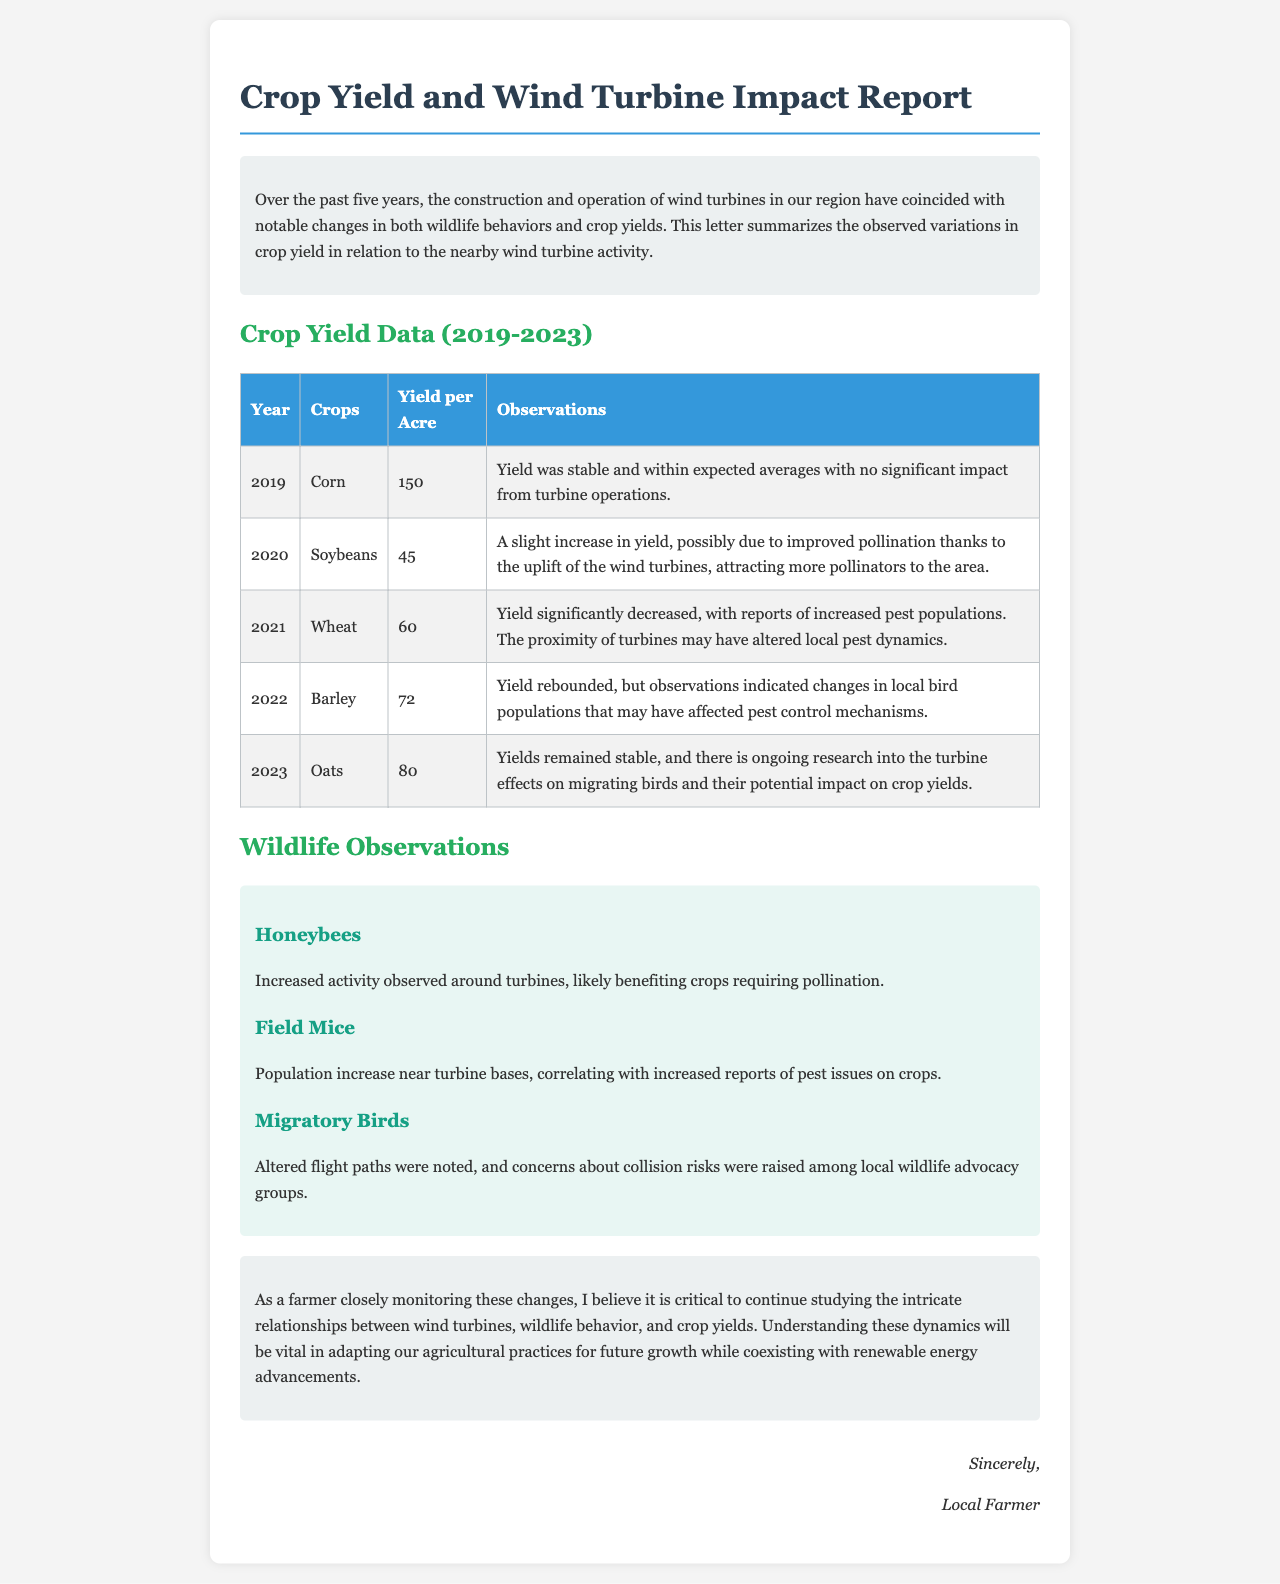what crop had the highest yield in 2019? The table indicates that the yield for corn in 2019 was 150.
Answer: Corn what was the yield per acre for soybeans in 2020? According to the document, the yield per acre for soybeans in 2020 was 45.
Answer: 45 which crop yielded the least in 2021? The report states that the yield for wheat in 2021 was the lowest among the crops listed.
Answer: Wheat what observation is associated with the barley yield in 2022? The document mentions changes in local bird populations affecting pest control mechanisms for barley.
Answer: Changes in local bird populations how has turbine activity affected honeybee populations? The wildlife section notes an increase in honeybee activity around the turbines.
Answer: Increased activity what relationship is observed between field mice and crop issues? The document states that increased field mice populations near turbine bases correlate with pest issues on crops.
Answer: Correlation with pest issues how many years does the crop yield data cover? The introduction indicates that the yield data spans over five years.
Answer: Five years what is the main conclusion drawn in the report? The conclusion emphasizes the importance of studying the relationship between wind turbines, wildlife, and crop yields.
Answer: Studying relationships in which year did wheat yields significantly decrease? The document specifies that wheat yields significantly decreased in the year 2021.
Answer: 2021 